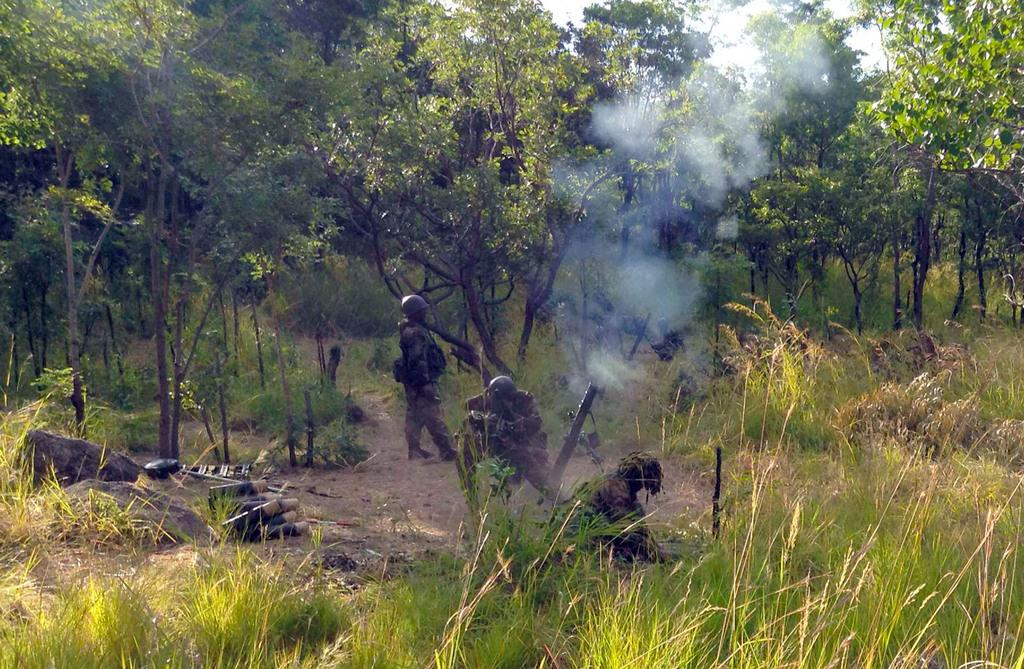What are the main subjects in the center of the image? There are soldiers in the center of the image. What type of vegetation can be seen at the top side of the image? There are trees at the top side of the image. What type of terrain is visible at the bottom side of the image? There is grassland at the bottom side of the image. Can you tell me how many bikes are parked near the soldiers in the image? There are no bikes present in the image; it only features soldiers, trees, and grassland. Is there a river flowing through the grassland at the bottom side of the image? There is no river visible in the image; it only shows grassland. 